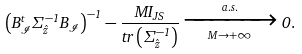Convert formula to latex. <formula><loc_0><loc_0><loc_500><loc_500>\left ( { B } _ { \mathcal { I } } ^ { t } \Sigma _ { \hat { z } } ^ { - 1 } { B } _ { \mathcal { I } } \right ) ^ { - 1 } - \frac { M { I } _ { J S } } { t r \left ( \Sigma _ { \hat { z } } ^ { - 1 } \right ) } \xrightarrow [ M \to + \infty ] { a . s . } 0 .</formula> 